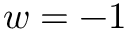<formula> <loc_0><loc_0><loc_500><loc_500>w = - 1</formula> 